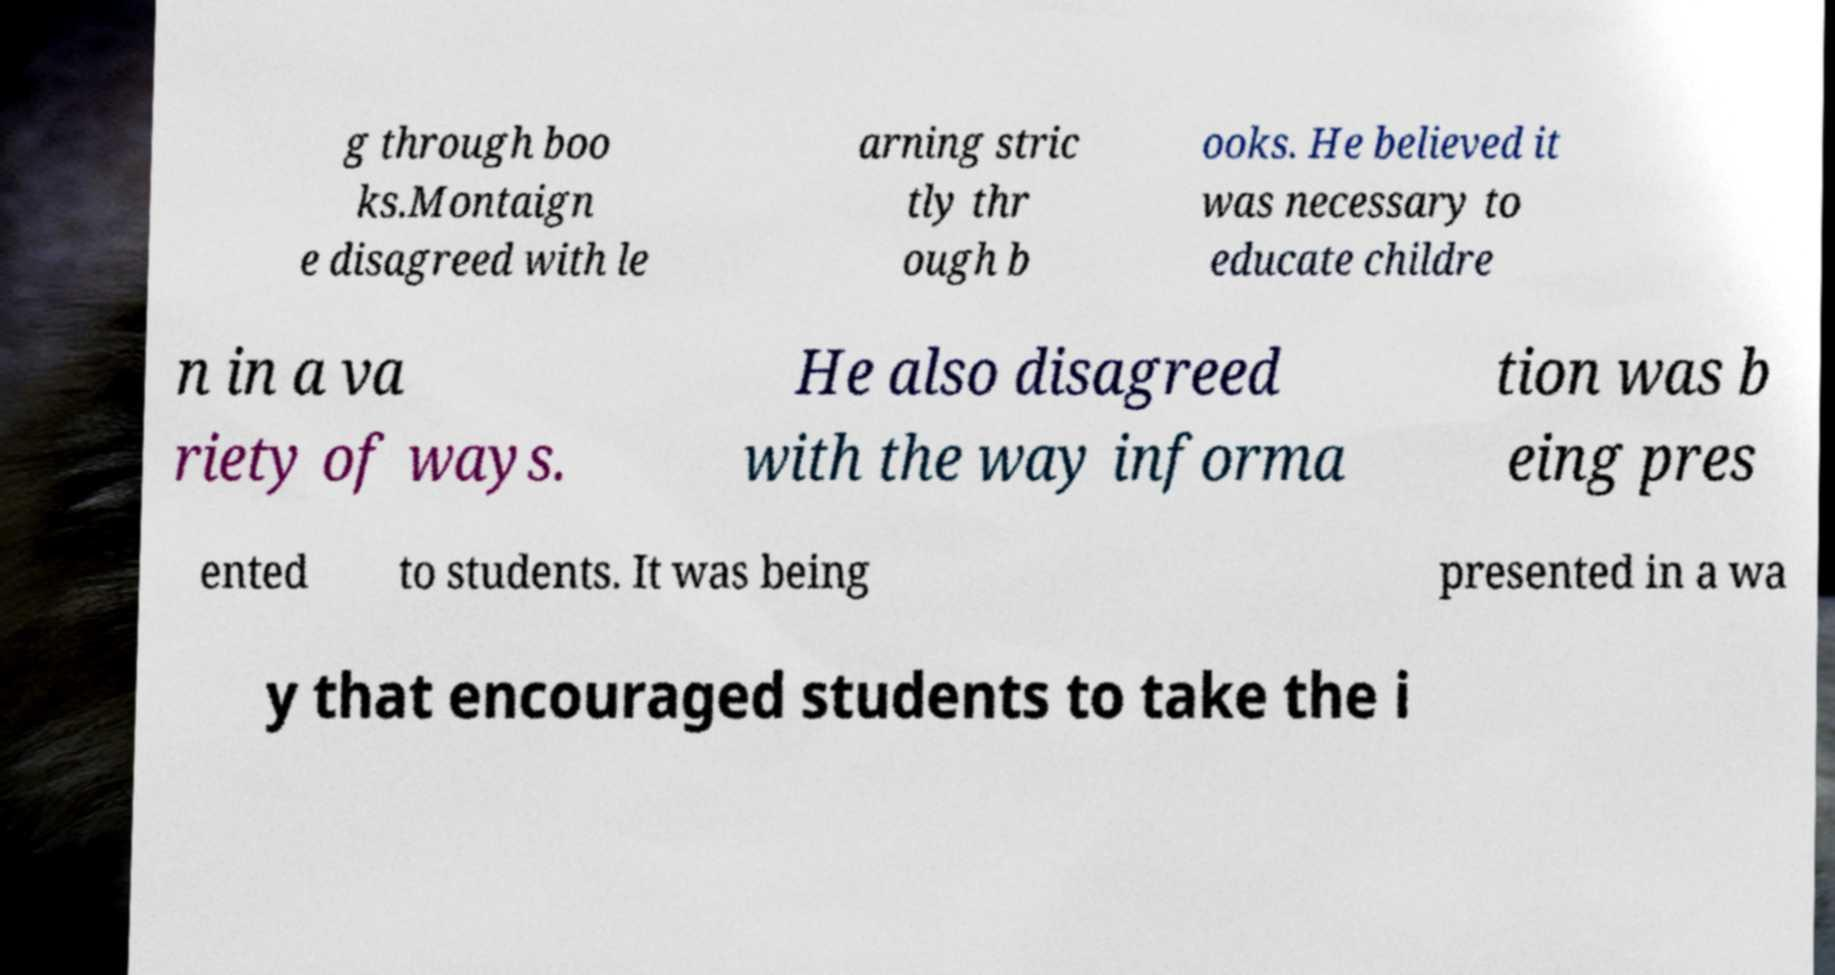Can you read and provide the text displayed in the image?This photo seems to have some interesting text. Can you extract and type it out for me? g through boo ks.Montaign e disagreed with le arning stric tly thr ough b ooks. He believed it was necessary to educate childre n in a va riety of ways. He also disagreed with the way informa tion was b eing pres ented to students. It was being presented in a wa y that encouraged students to take the i 